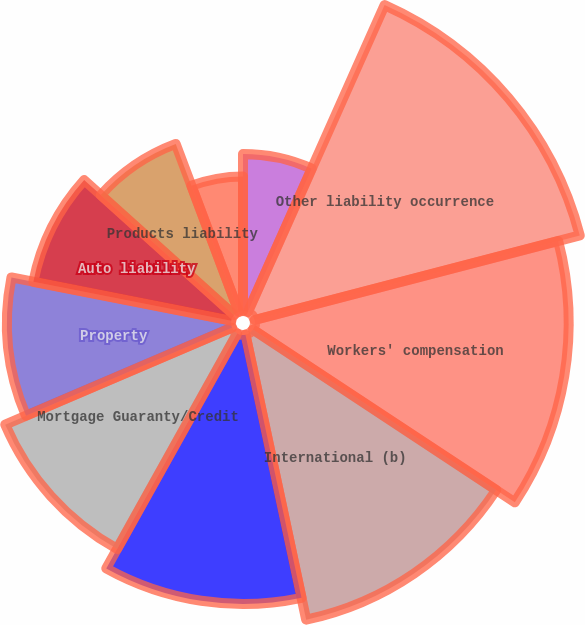Convert chart to OTSL. <chart><loc_0><loc_0><loc_500><loc_500><pie_chart><fcel>At December 31 (in millions)<fcel>Other liability occurrence<fcel>Workers' compensation<fcel>International (b)<fcel>Other liability claims made<fcel>Mortgage Guaranty/Credit<fcel>Property<fcel>Auto liability<fcel>Products liability<fcel>Medical malpractice<nl><fcel>6.67%<fcel>14.28%<fcel>13.33%<fcel>12.38%<fcel>11.43%<fcel>10.48%<fcel>9.52%<fcel>8.57%<fcel>7.62%<fcel>5.72%<nl></chart> 